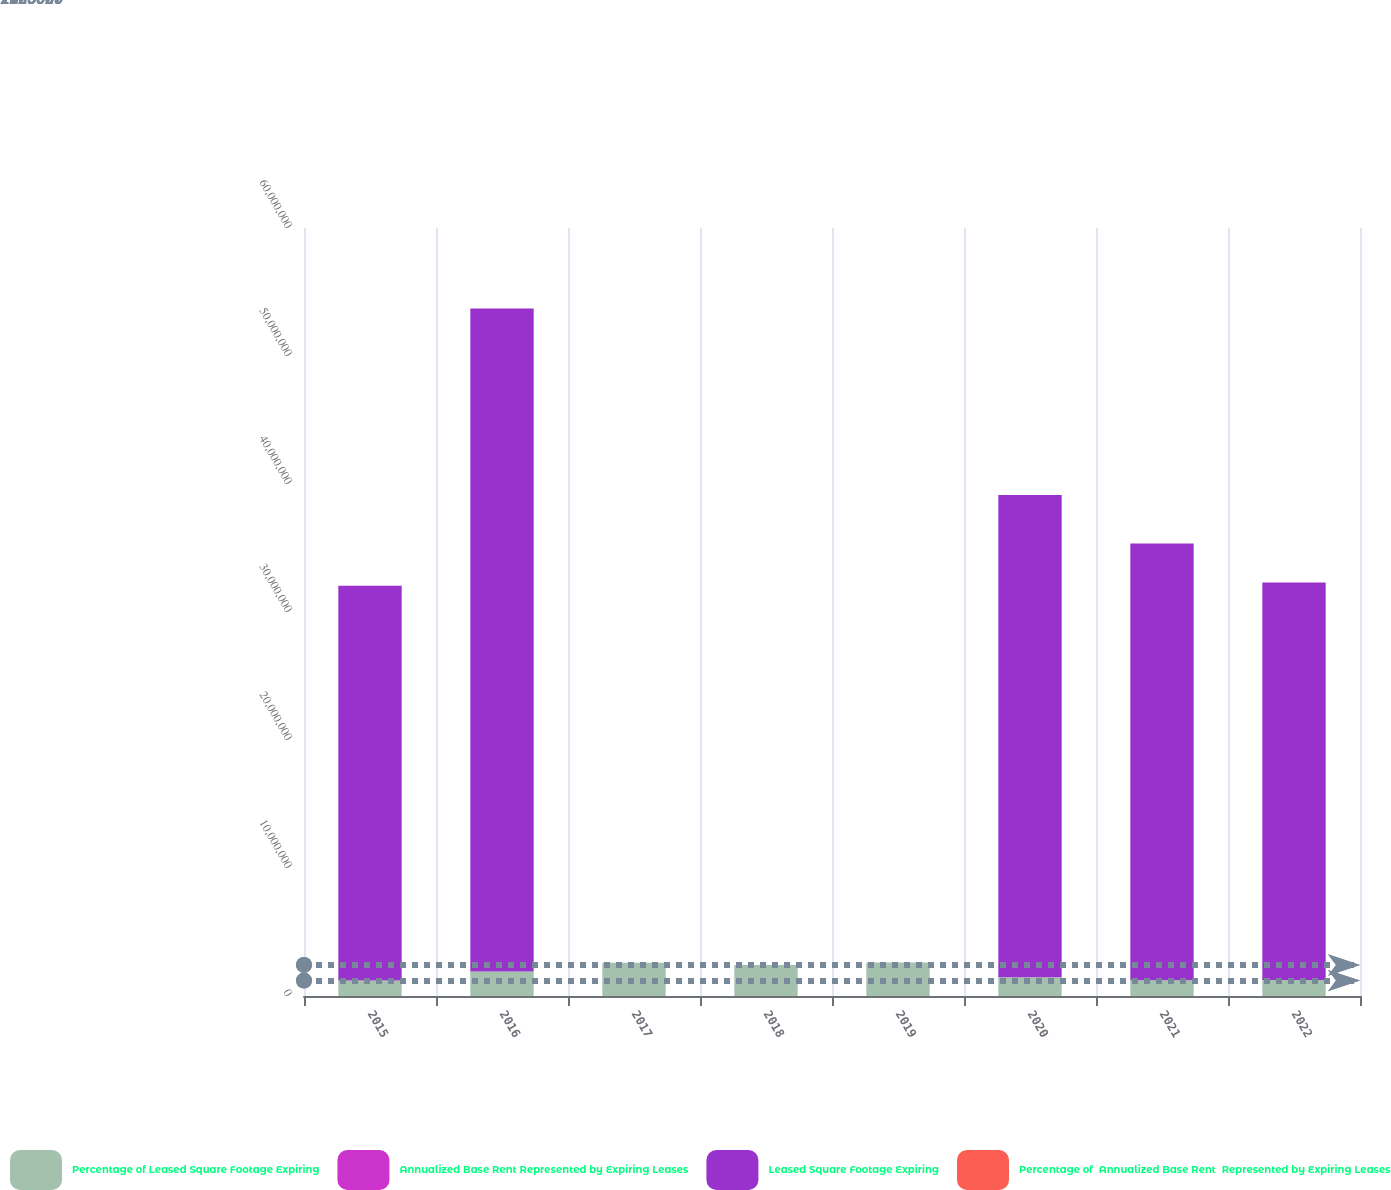<chart> <loc_0><loc_0><loc_500><loc_500><stacked_bar_chart><ecel><fcel>2015<fcel>2016<fcel>2017<fcel>2018<fcel>2019<fcel>2020<fcel>2021<fcel>2022<nl><fcel>Percentage of Leased Square Footage Expiring<fcel>1.203e+06<fcel>1.907e+06<fcel>2.602e+06<fcel>2.425e+06<fcel>2.619e+06<fcel>1.471e+06<fcel>1.23e+06<fcel>1.257e+06<nl><fcel>Annualized Base Rent Represented by Expiring Leases<fcel>6<fcel>10<fcel>14<fcel>13<fcel>14<fcel>8<fcel>6<fcel>6<nl><fcel>Leased Square Footage Expiring<fcel>3.0857e+07<fcel>5.1812e+07<fcel>14<fcel>14<fcel>14<fcel>3.7669e+07<fcel>3.4128e+07<fcel>3.1054e+07<nl><fcel>Percentage of  Annualized Base Rent  Represented by Expiring Leases<fcel>6<fcel>11<fcel>14<fcel>12<fcel>13<fcel>8<fcel>7<fcel>6<nl></chart> 